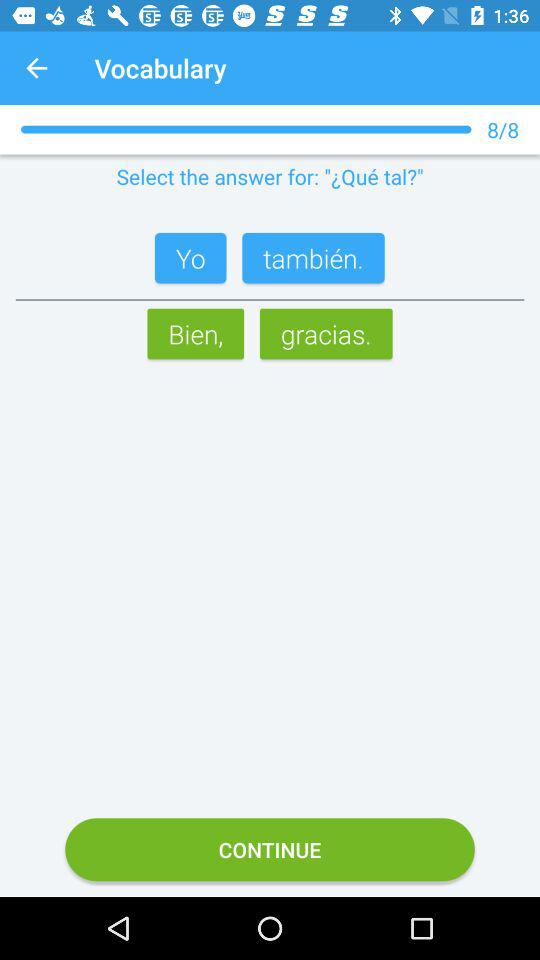What is the current question number? The current question number is 8. 